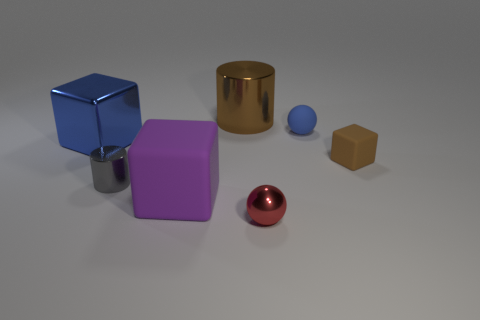Subtract all large blocks. How many blocks are left? 1 Add 2 small red objects. How many objects exist? 9 Subtract all spheres. How many objects are left? 5 Add 4 big blue metal cubes. How many big blue metal cubes exist? 5 Subtract 0 green cubes. How many objects are left? 7 Subtract all big purple rubber objects. Subtract all big yellow rubber balls. How many objects are left? 6 Add 5 large brown shiny objects. How many large brown shiny objects are left? 6 